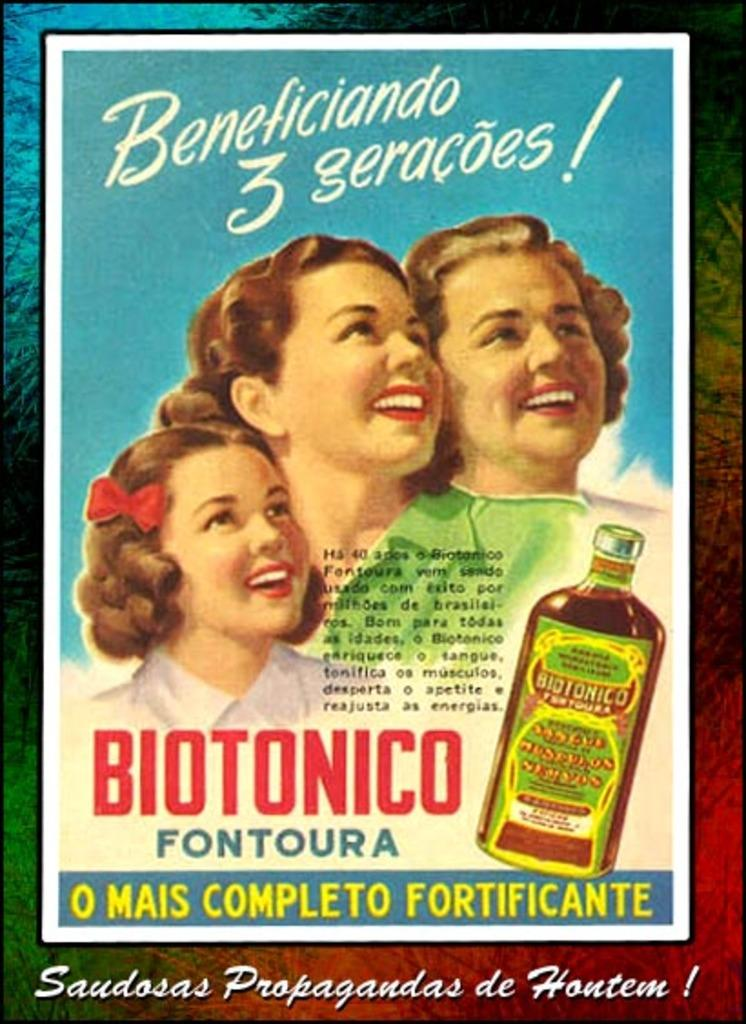Provide a one-sentence caption for the provided image. An advertisement poster for a product called Biotonico. 